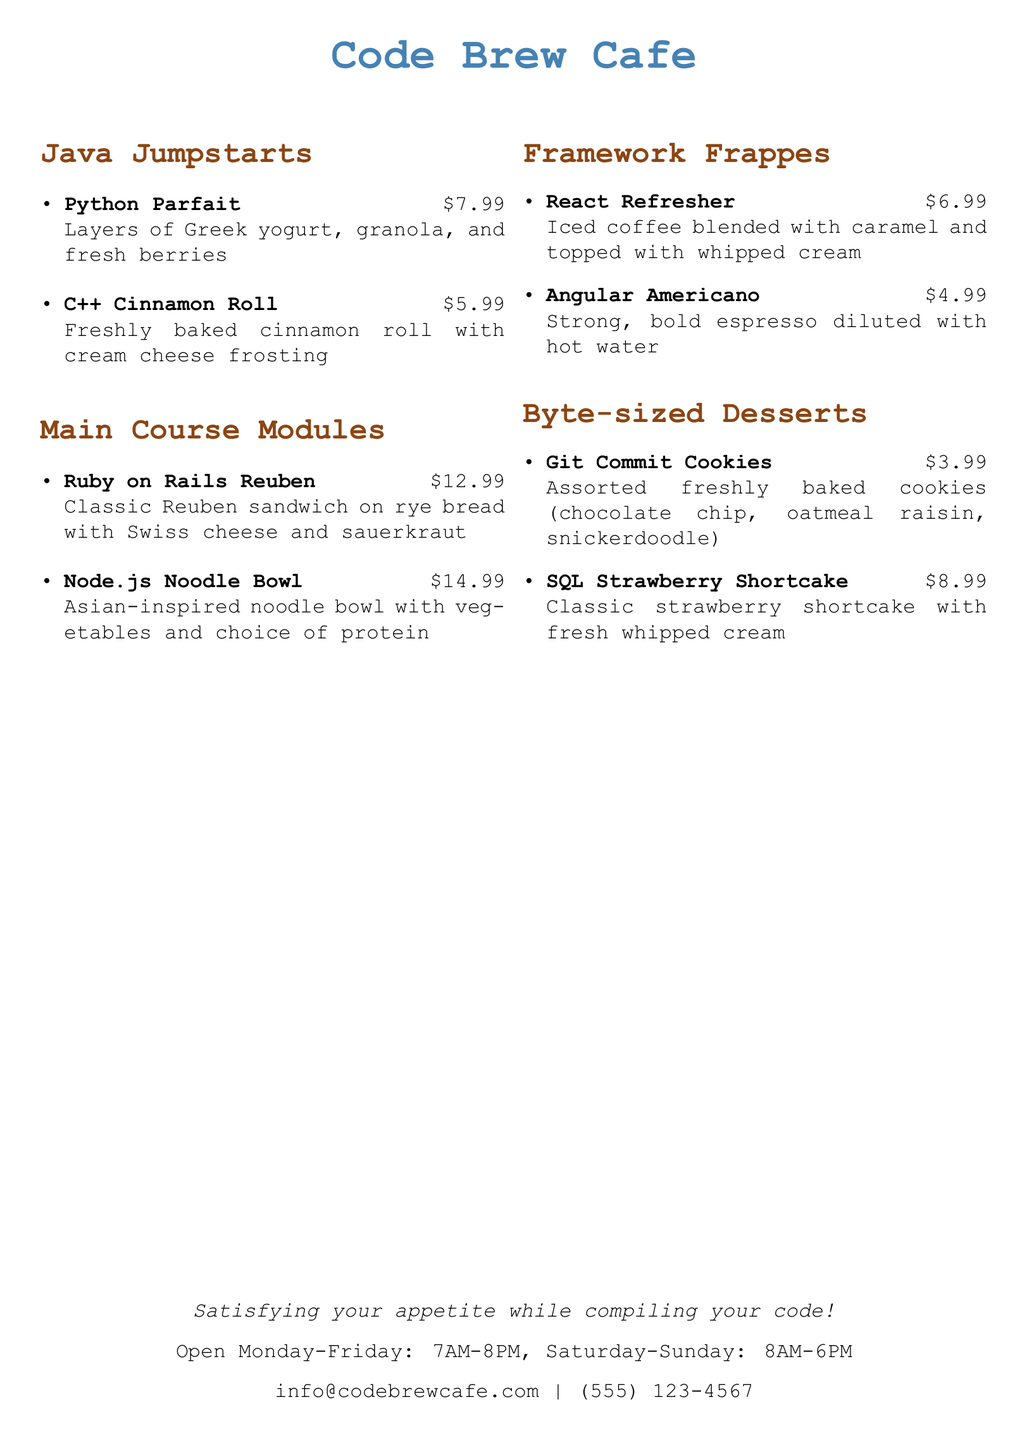What is the name of the cafe? The name of the cafe is mentioned at the top of the document in a large font.
Answer: Code Brew Cafe What is the price of the Python Parfait? The document lists prices next to each menu item, and the Python Parfait's price is included.
Answer: $7.99 What type of sandwich is the Ruby on Rails Reuben? The document briefly describes the Ruby on Rails Reuben under its name in the menu.
Answer: Classic Reuben How many items are in the Byte-sized Desserts section? The document provides a list of items in the Byte-sized Desserts section, and counting them gives the answer.
Answer: 2 What drink is made with iced coffee and caramel? The menu describes the ingredients of the Framework Frappes, specifically the React Refresher.
Answer: React Refresher What are the opening hours on Saturday? The document details the cafe's operating hours and specifies them for Saturday.
Answer: 8AM-6PM How much does the Angular Americano cost? The price is given next to the Angular Americano in the menu.
Answer: $4.99 Which dessert features strawberries? The document describes each dessert, and the one that mentions strawberries is identified.
Answer: SQL Strawberry Shortcake What is the contact email for the cafe? The document includes the cafe's contact information, specifically the email address.
Answer: info@codebrewcafe.com 